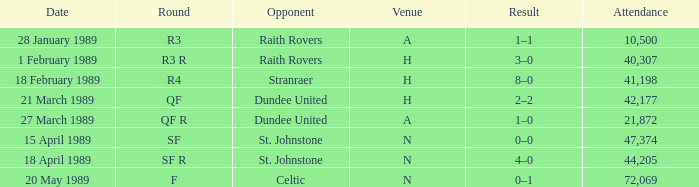On which date does the round occur in sf? 15 April 1989. 